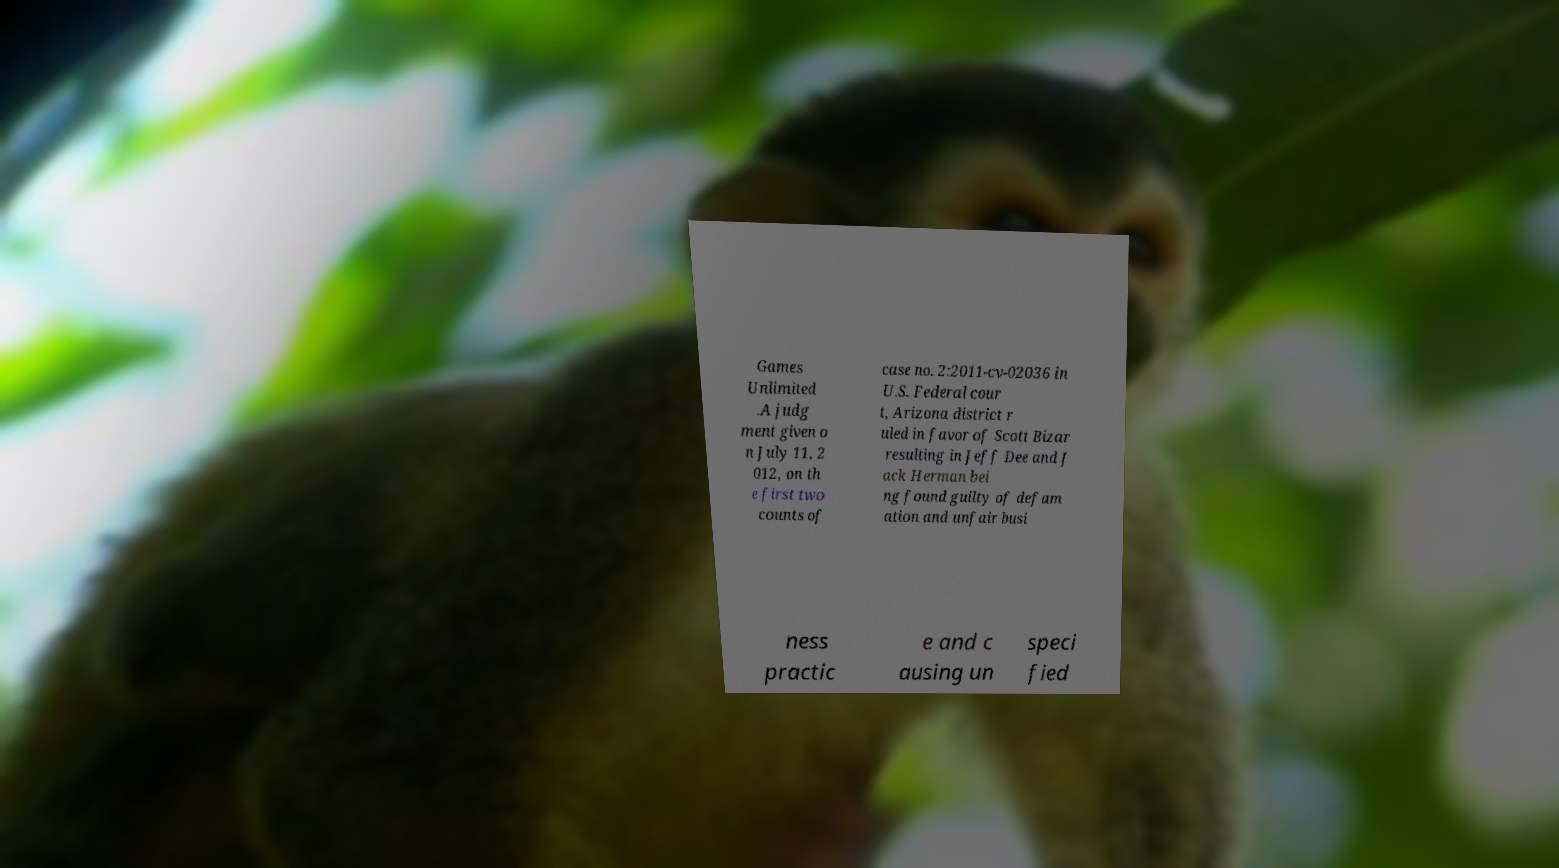Please read and relay the text visible in this image. What does it say? Games Unlimited .A judg ment given o n July 11, 2 012, on th e first two counts of case no. 2:2011-cv-02036 in U.S. Federal cour t, Arizona district r uled in favor of Scott Bizar resulting in Jeff Dee and J ack Herman bei ng found guilty of defam ation and unfair busi ness practic e and c ausing un speci fied 